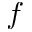<formula> <loc_0><loc_0><loc_500><loc_500>f</formula> 